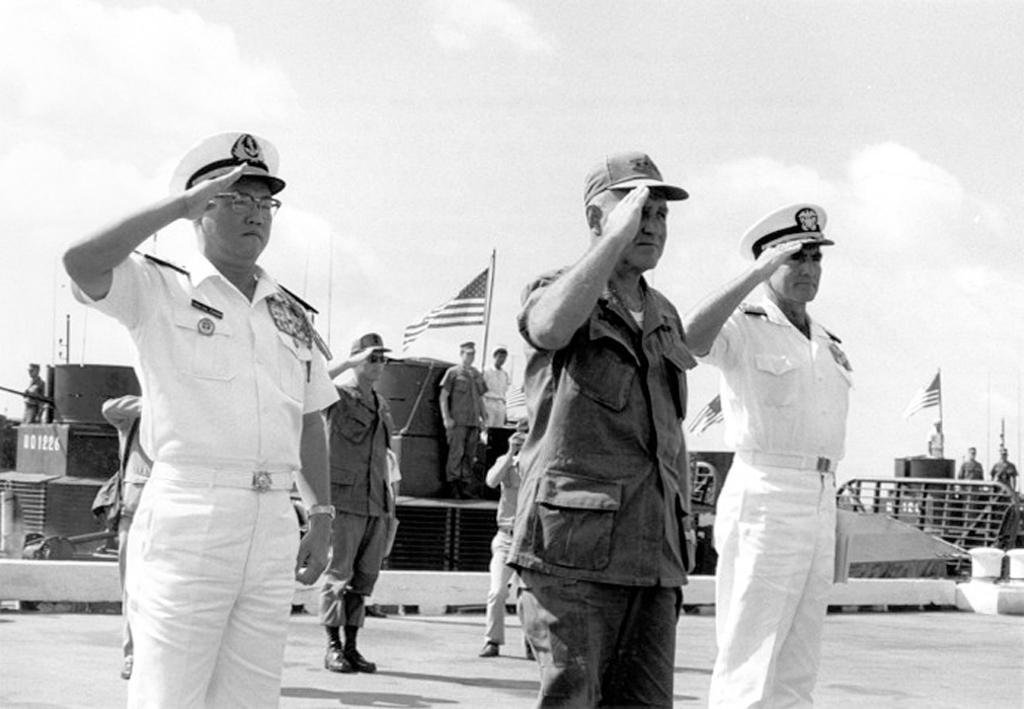Please provide a concise description of this image. In this image we can see four men standing on the ground and they are doing honor salute. Here we can see a man and looks like he is capturing an image. In the background, we can see a few people. Here we can see the flag poles. This is a sky with clouds. 